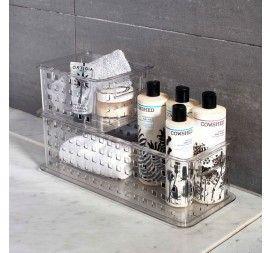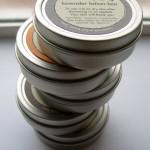The first image is the image on the left, the second image is the image on the right. Analyze the images presented: Is the assertion "A circular bar of soap has a bee imprinted on it." valid? Answer yes or no. No. 